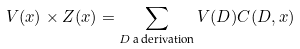Convert formula to latex. <formula><loc_0><loc_0><loc_500><loc_500>V ( x ) \times Z ( x ) = \sum _ { D \, \text {a derivation} } V ( D ) C ( D , x )</formula> 